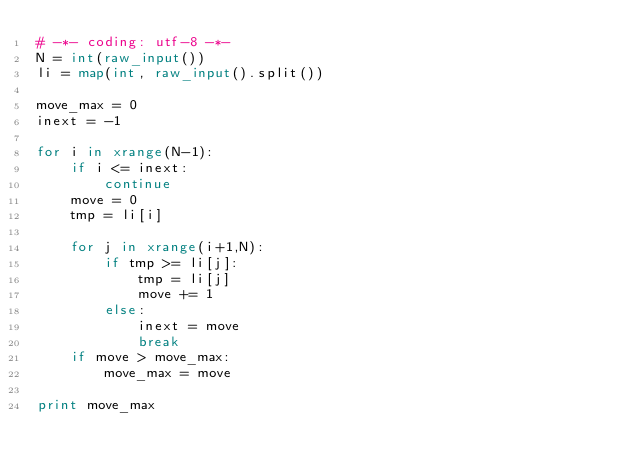Convert code to text. <code><loc_0><loc_0><loc_500><loc_500><_Python_># -*- coding: utf-8 -*-
N = int(raw_input())
li = map(int, raw_input().split())

move_max = 0
inext = -1

for i in xrange(N-1):
    if i <= inext:
        continue
    move = 0
    tmp = li[i]
    
    for j in xrange(i+1,N):
        if tmp >= li[j]:
            tmp = li[j]
            move += 1
    	else:
            inext = move
            break
    if move > move_max:
        move_max = move

print move_max
</code> 